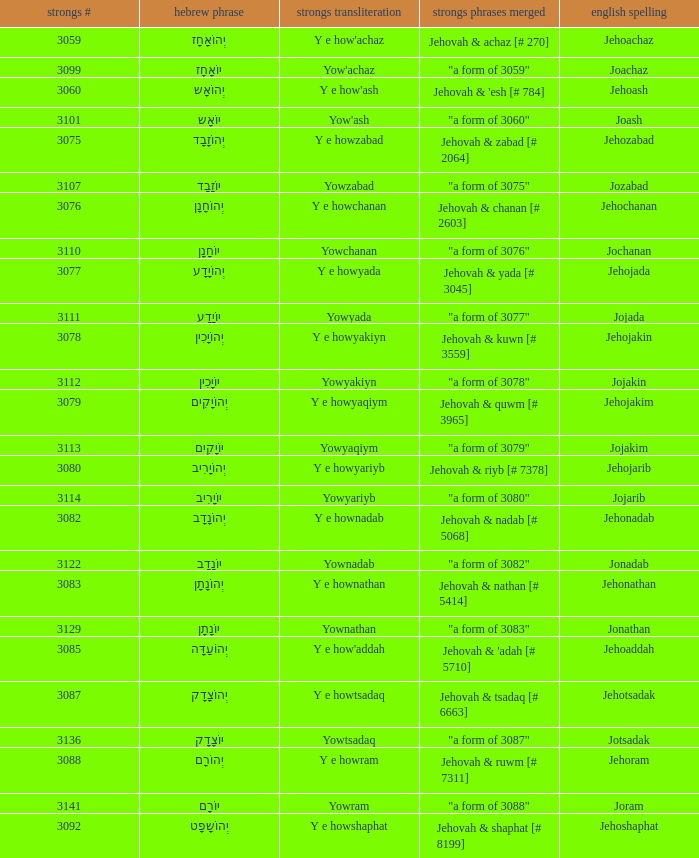What is the english spelling of the word that has the strongs trasliteration of y e howram? Jehoram. 